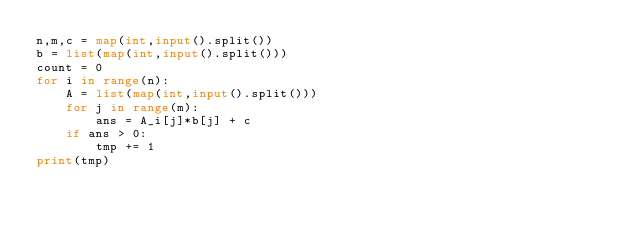<code> <loc_0><loc_0><loc_500><loc_500><_Python_>n,m,c = map(int,input().split())
b = list(map(int,input().split()))
count = 0
for i in range(n):
    A = list(map(int,input().split()))
    for j in range(m):
        ans = A_i[j]*b[j] + c
    if ans > 0:
        tmp += 1
print(tmp)</code> 